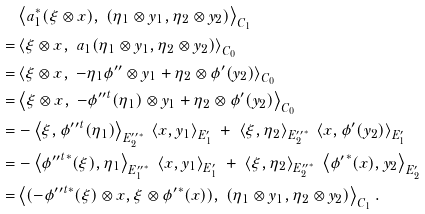<formula> <loc_0><loc_0><loc_500><loc_500>& \left \langle a _ { 1 } ^ { * } ( \xi \otimes x ) , \ ( \eta _ { 1 } \otimes y _ { 1 } , \eta _ { 2 } \otimes y _ { 2 } ) \right \rangle _ { C _ { 1 } } \\ = & \left \langle \xi \otimes x , \ a _ { 1 } ( \eta _ { 1 } \otimes y _ { 1 } , \eta _ { 2 } \otimes y _ { 2 } ) \right \rangle _ { C _ { 0 } } \\ = & \left \langle \xi \otimes x , \ - \eta _ { 1 } \phi ^ { \prime \prime } \otimes y _ { 1 } + \eta _ { 2 } \otimes \phi ^ { \prime } ( y _ { 2 } ) \right \rangle _ { C _ { 0 } } \\ = & \left \langle \xi \otimes x , \ - { \phi ^ { \prime \prime } } ^ { t } ( \eta _ { 1 } ) \otimes y _ { 1 } + \eta _ { 2 } \otimes \phi ^ { \prime } ( y _ { 2 } ) \right \rangle _ { C _ { 0 } } \\ = & - \left \langle \xi , { \phi ^ { \prime \prime } } ^ { t } ( \eta _ { 1 } ) \right \rangle _ { { E _ { 2 } ^ { \prime \prime } } ^ { * } } \ \left \langle x , y _ { 1 } \right \rangle _ { E _ { 1 } ^ { \prime } } \ + \ \left \langle \xi , \eta _ { 2 } \right \rangle _ { { E _ { 2 } ^ { \prime \prime } } ^ { * } } \ \left \langle x , \phi ^ { \prime } ( y _ { 2 } ) \right \rangle _ { E _ { 1 } ^ { \prime } } \\ = & - \left \langle { \phi ^ { \prime \prime } } ^ { t * } ( \xi ) , \eta _ { 1 } \right \rangle _ { { E _ { 1 } ^ { \prime \prime } } ^ { * } } \ \left \langle x , y _ { 1 } \right \rangle _ { E _ { 1 } ^ { \prime } } \ + \ \left \langle \xi , \eta _ { 2 } \right \rangle _ { { E _ { 2 } ^ { \prime \prime } } ^ { * } } \ \left \langle { \phi ^ { \prime } } ^ { * } ( x ) , y _ { 2 } \right \rangle _ { E _ { 2 } ^ { \prime } } \\ = & \left \langle ( - { \phi ^ { \prime \prime } } ^ { t * } ( \xi ) \otimes x , \xi \otimes { \phi ^ { \prime } } ^ { * } ( x ) ) , \ ( \eta _ { 1 } \otimes y _ { 1 } , \eta _ { 2 } \otimes y _ { 2 } ) \right \rangle _ { C _ { 1 } } .</formula> 